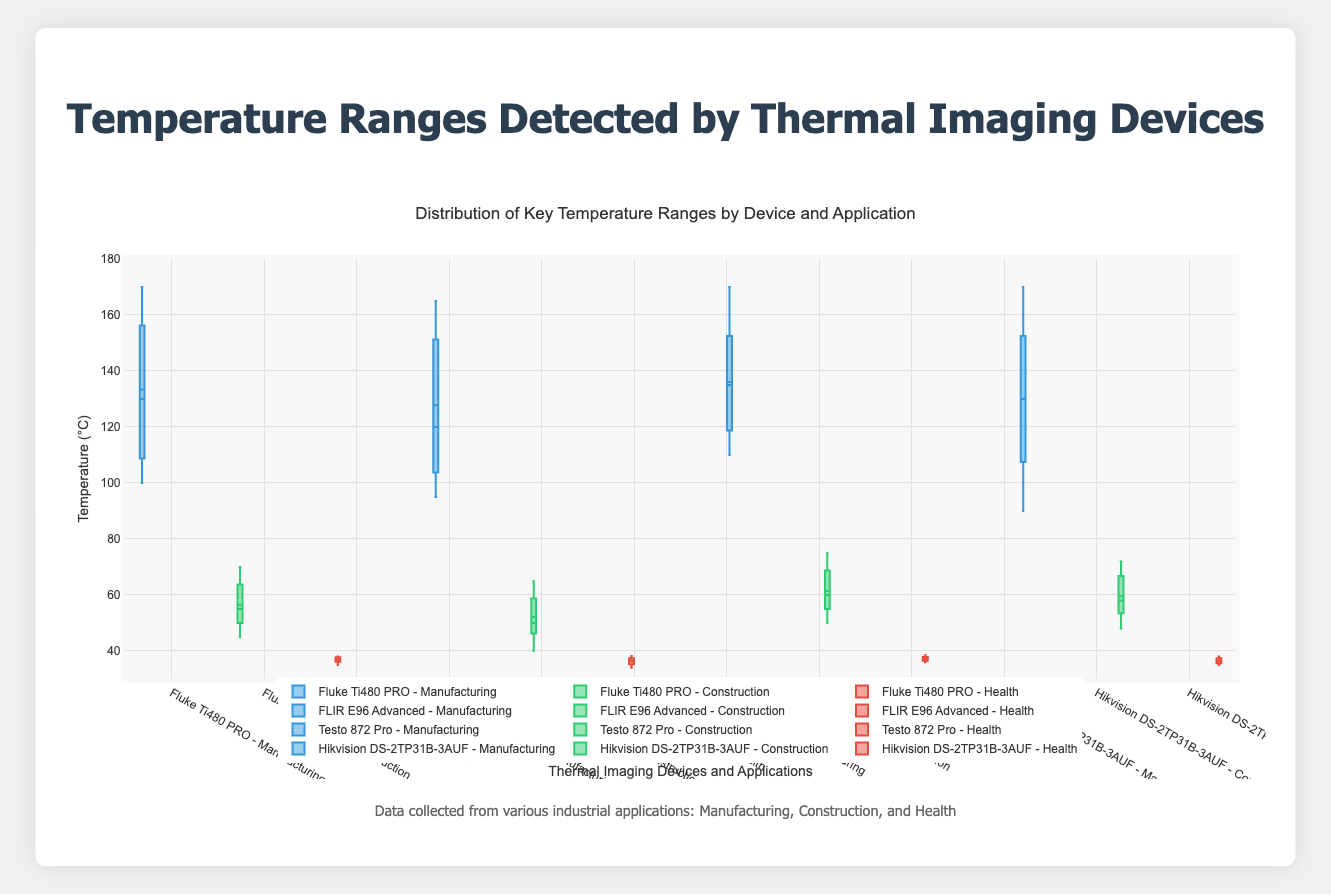What's the highest temperature detected in Manufacturing by the Fluke Ti480 PRO? The box plot for the Fluke Ti480 PRO in Manufacturing will show the maximum value at the upper whisker of that specific box.
Answer: 170°C What is the median temperature for the FLIR E96 Advanced in Health applications? The line inside the box plot for FLIR E96 Advanced in Health will indicate the median temperature.
Answer: 36.5°C How do the interquartile ranges (IQR) of Construction temperatures compare between Testo 872 Pro and Hikvision DS-2TP31B-3AUF? The IQR is the range between the first quartile (Q1) and the third quartile (Q3). You can compare the lengths of the boxes for Testo 872 Pro and Hikvision DS-2TP31B-3AUF for Construction.
Answer: Testo 872 Pro IQR > Hikvision DS-2TP31B-3AUF IQR Which device shows the widest temperature range (max-min) for Manufacturing applications? Find the devices' whisker lengths and compare the widths (max-min values) for Manufacturing.
Answer: Fluke Ti480 PRO What is the lowest temperature recorded by any device in Health applications? The lowest temperature across all devices in Health can be determined by identifying the lowest point of the whiskers for each device.
Answer: 34°C Which thermal imaging device detected the most consistent temperature range in Construction (smallest IQR)? The device with the smallest IQR (box length) in Construction shows the most consistent temperature range.
Answer: Hikvision DS-2TP31B-3AUF What are the median temperatures detected in Manufacturing by Fluke Ti480 PRO and FLIR E96 Advanced? Look for the median lines inside the Manufacturing boxes of Fluke Ti480 PRO and FLIR E96 Advanced.
Answer: 125°C for Fluke Ti480 PRO and 120°C for FLIR E96 Advanced How does the average temperature for Health detected by Testo 872 Pro compare to the average for FLIR E96 Advanced? Calculate the mean values, often shown in box plots as a dot or indicated explicitly when boxmean is included. Compare these averages.
Answer: Testo 872 Pro approximate average > FLIR E96 Advanced approximate average Which application has the most outliers for the FLIR E96 Advanced? Count the outlier points plotted separately outside the main box in each application (Manufacturing, Construction, Health) for FLIR E96 Advanced.
Answer: Construction 